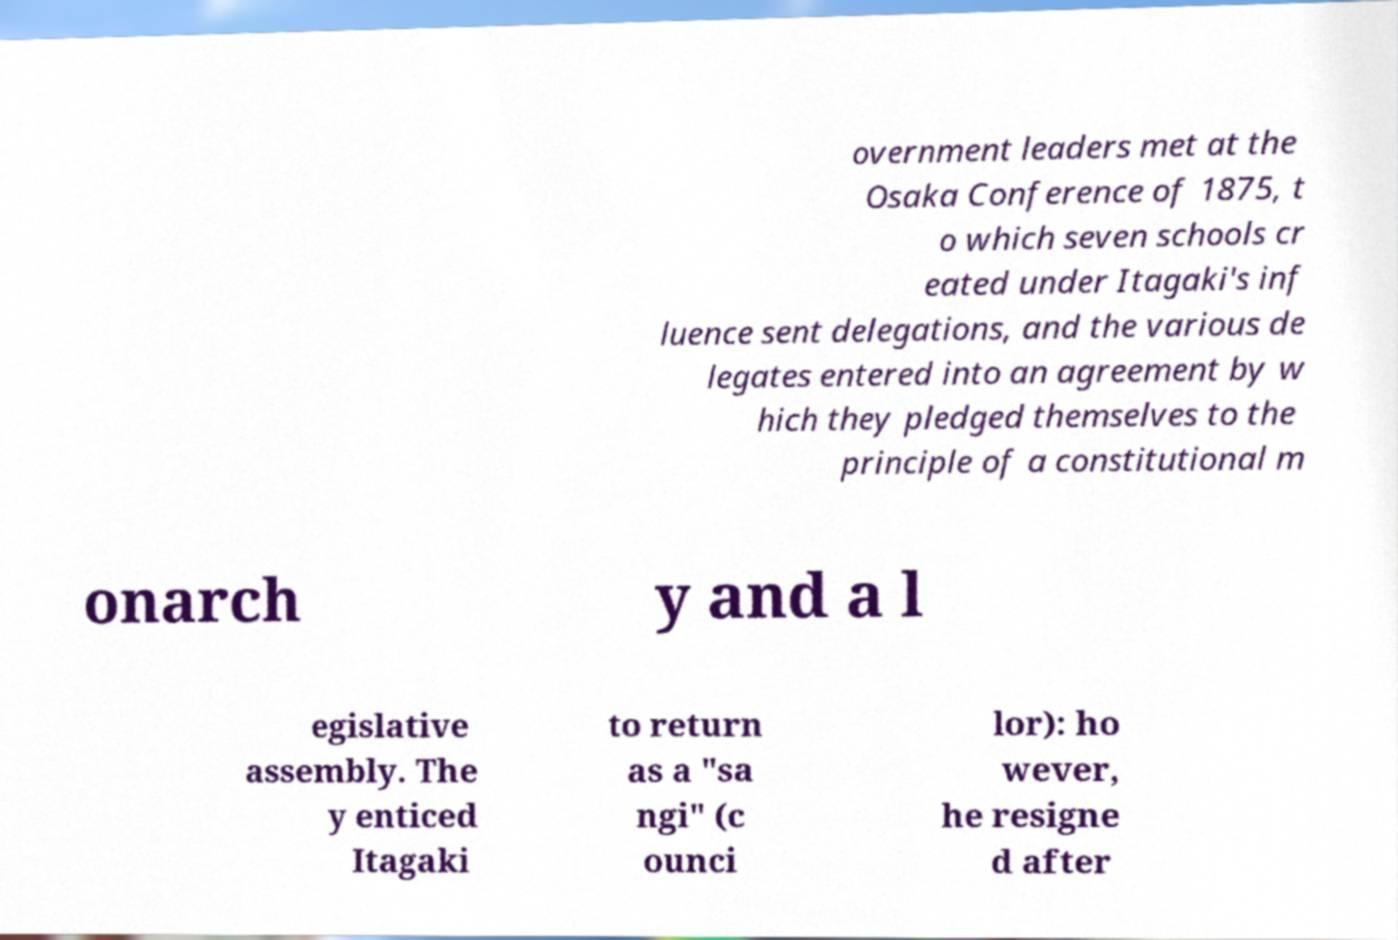Could you assist in decoding the text presented in this image and type it out clearly? overnment leaders met at the Osaka Conference of 1875, t o which seven schools cr eated under Itagaki's inf luence sent delegations, and the various de legates entered into an agreement by w hich they pledged themselves to the principle of a constitutional m onarch y and a l egislative assembly. The y enticed Itagaki to return as a "sa ngi" (c ounci lor): ho wever, he resigne d after 